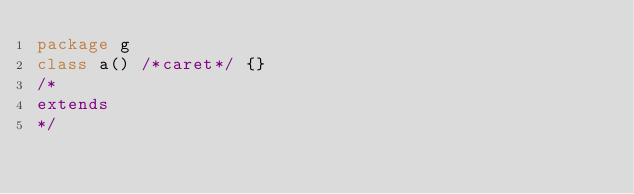<code> <loc_0><loc_0><loc_500><loc_500><_Scala_>package g
class a() /*caret*/ {}
/*
extends
*/</code> 